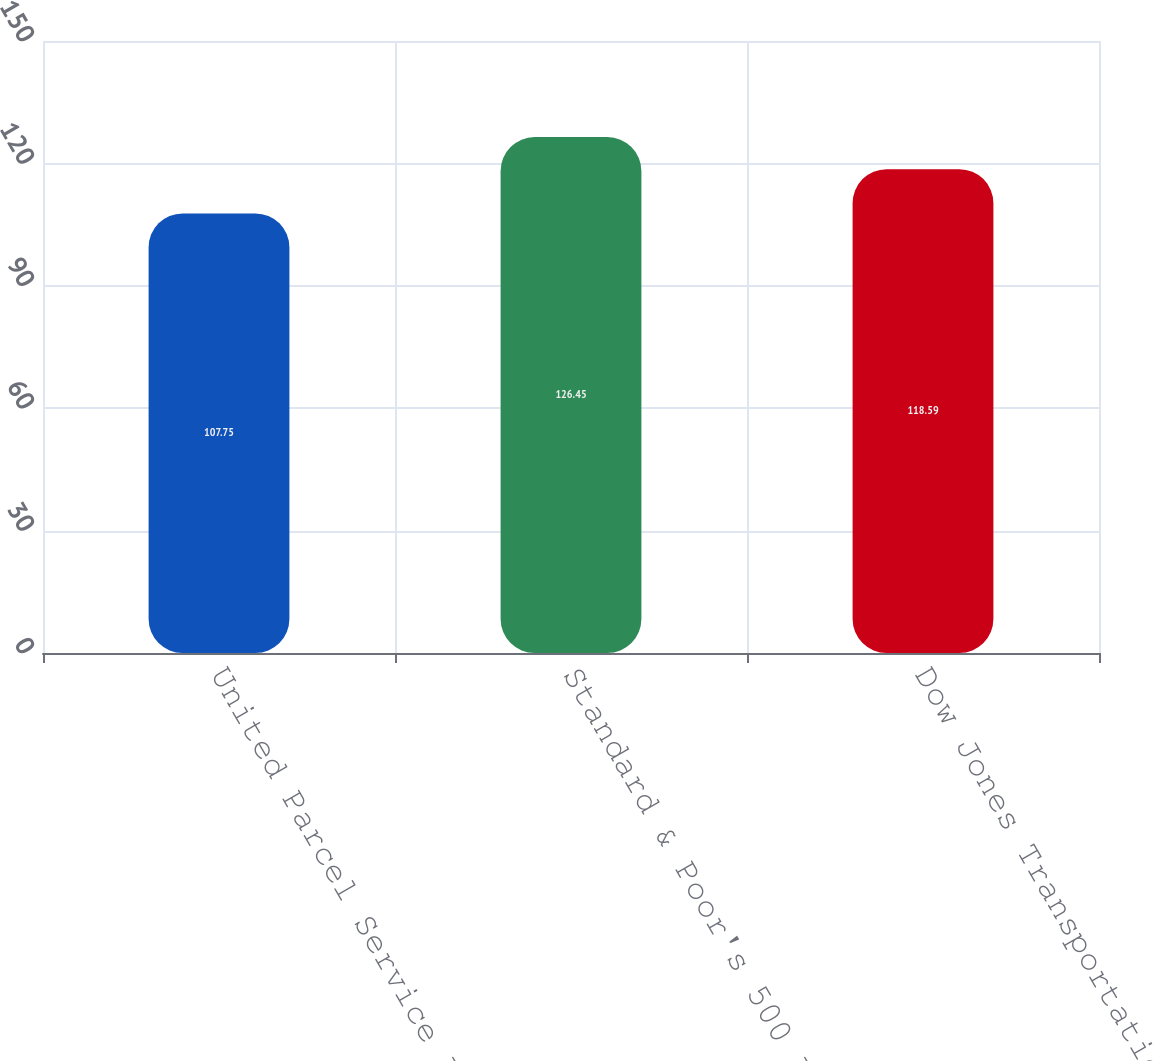Convert chart to OTSL. <chart><loc_0><loc_0><loc_500><loc_500><bar_chart><fcel>United Parcel Service Inc<fcel>Standard & Poor's 500 Index<fcel>Dow Jones Transportation<nl><fcel>107.75<fcel>126.45<fcel>118.59<nl></chart> 